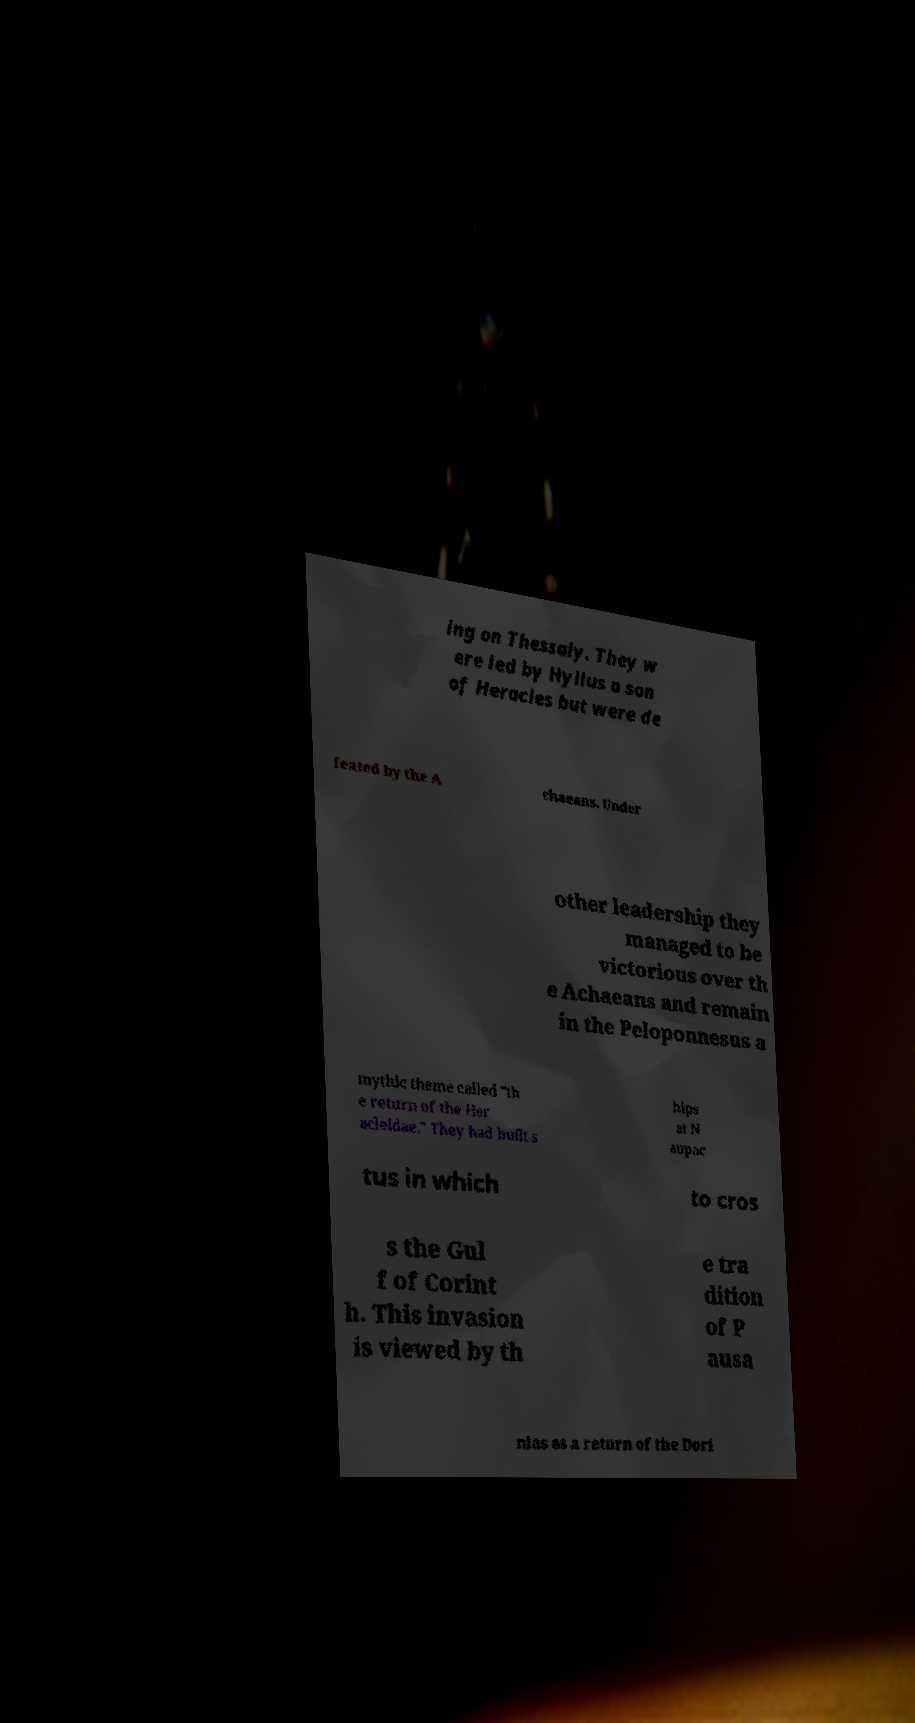Could you extract and type out the text from this image? ing on Thessaly. They w ere led by Hyllus a son of Heracles but were de feated by the A chaeans. Under other leadership they managed to be victorious over th e Achaeans and remain in the Peloponnesus a mythic theme called "th e return of the Her acleidae." They had built s hips at N aupac tus in which to cros s the Gul f of Corint h. This invasion is viewed by th e tra dition of P ausa nias as a return of the Dori 